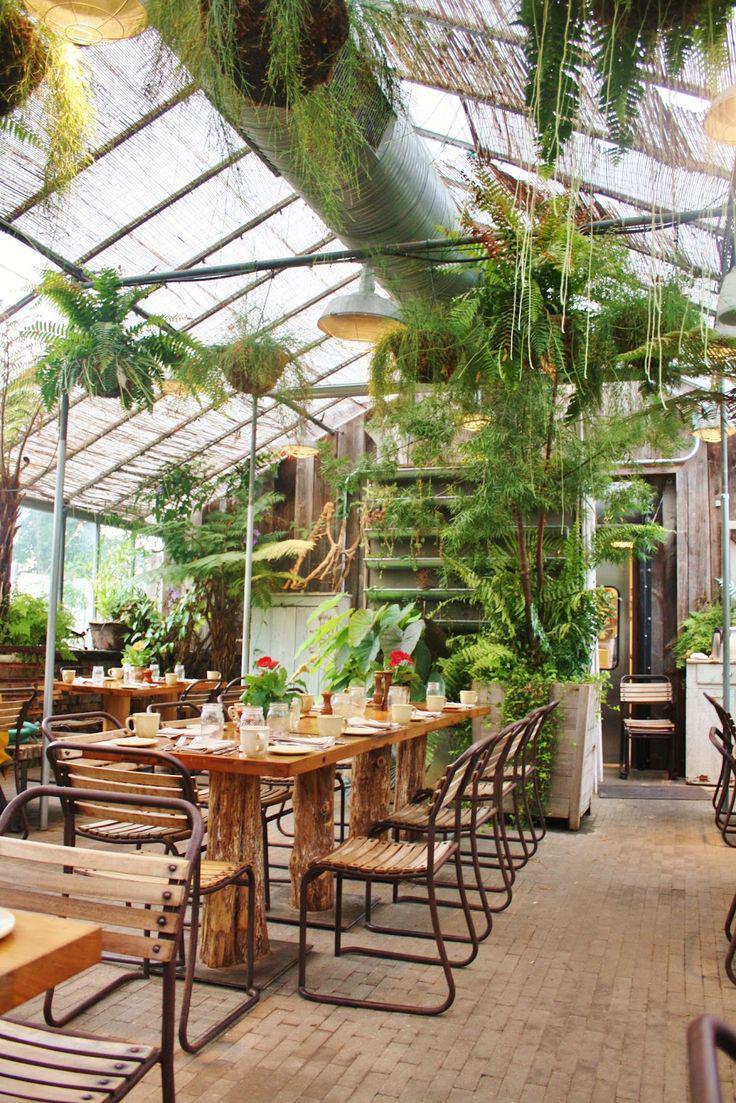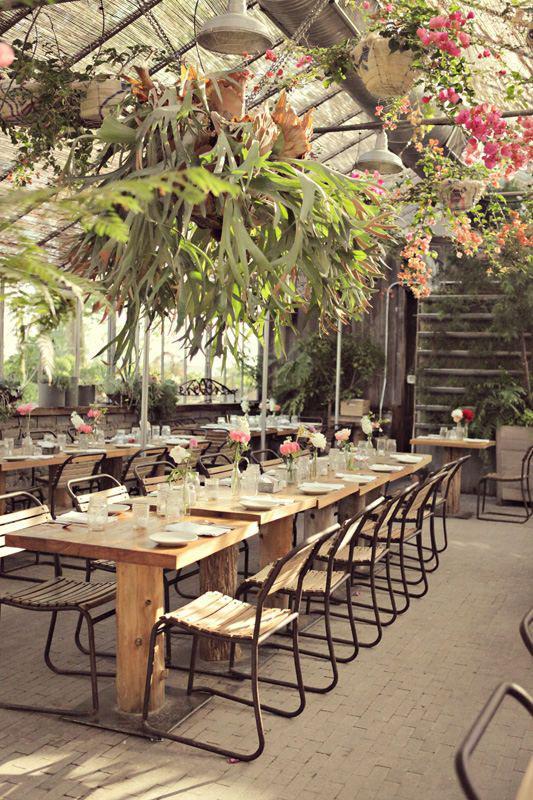The first image is the image on the left, the second image is the image on the right. Evaluate the accuracy of this statement regarding the images: "The left and right image each contain at least five square light brown wooden dining tables.". Is it true? Answer yes or no. Yes. 